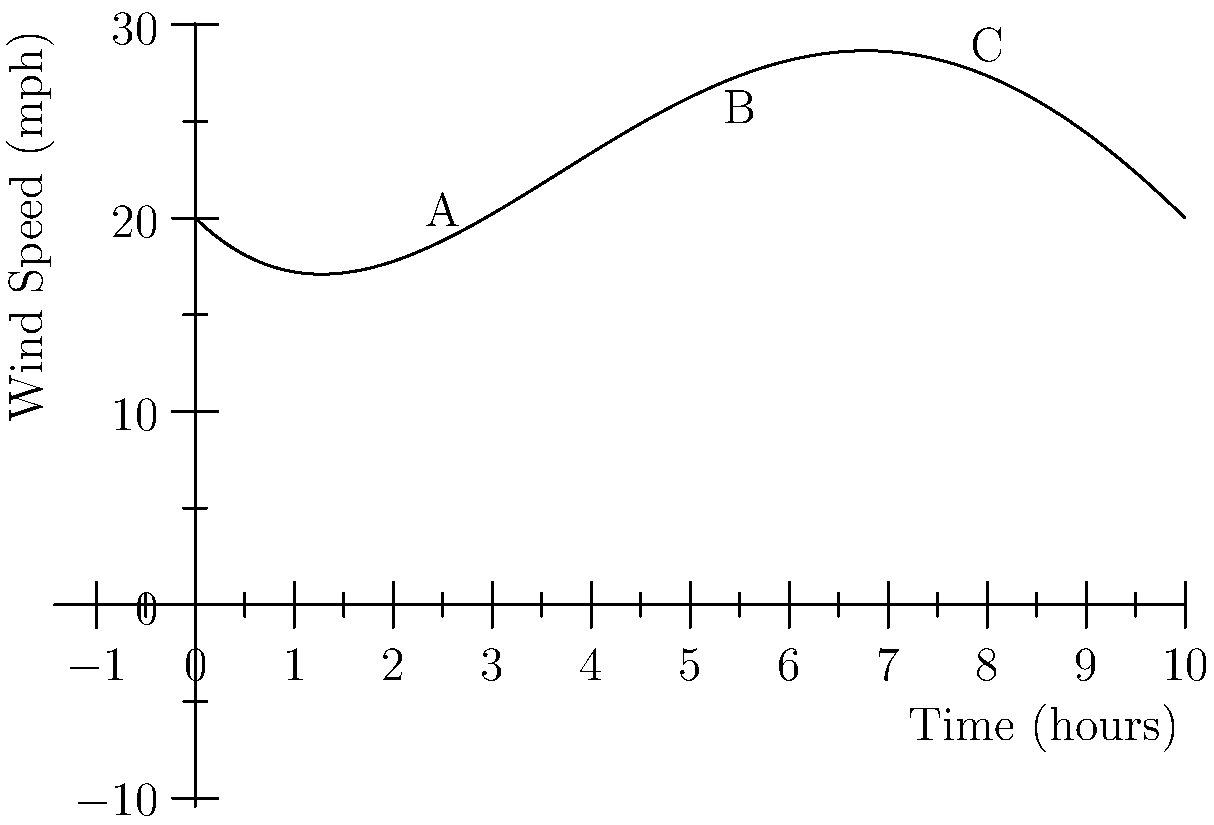The graph shows wind speed variations during a storm over a 10-hour period, modeled by a fourth-degree polynomial function. Identify the number of local maxima and minima in the wind speed, and determine at which point (A, B, or C) the wind speed is increasing most rapidly. To answer this question, we need to analyze the graph and its turning points:

1. Counting local maxima and minima:
   - The graph has two turning points, creating one local maximum and one local minimum.
   - The local maximum occurs around 4 hours into the storm.
   - The local minimum occurs around 7 hours into the storm.

2. Determining the point of most rapid wind speed increase:
   - We need to identify where the slope of the curve is steepest in the positive direction.
   - Point A: The curve is rising steeply, indicating rapid wind speed increase.
   - Point B: The curve is decreasing, so wind speed is not increasing here.
   - Point C: The curve is rising, but less steeply than at point A.

3. Conclusion:
   - There is 1 local maximum and 1 local minimum.
   - The wind speed is increasing most rapidly at point A, where the positive slope is steepest.
Answer: 2 turning points; Point A 